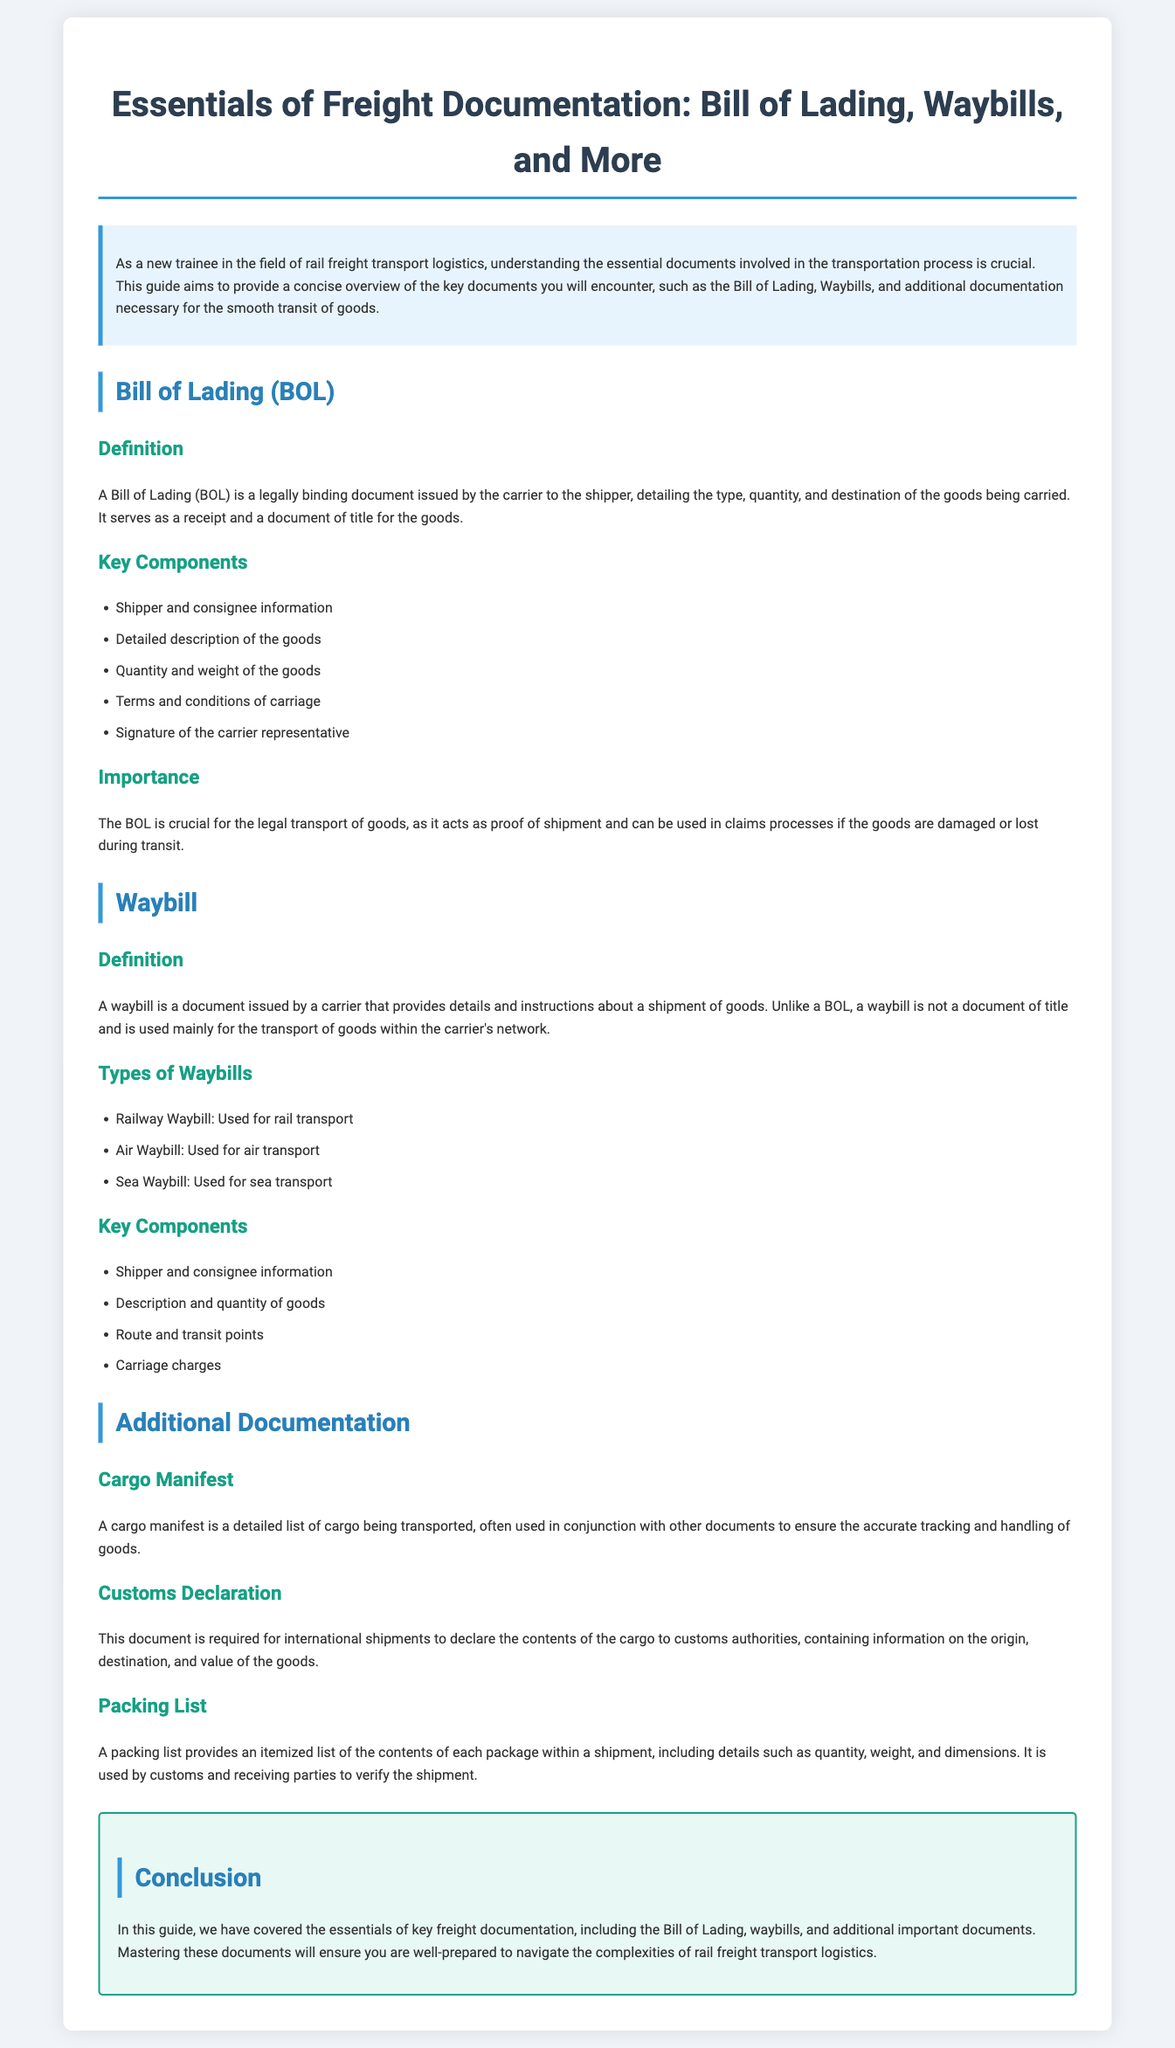What is the main purpose of the Bill of Lading? The main purpose of the Bill of Lading is to document the type, quantity, and destination of the goods being carried, serving as a receipt and a document of title.
Answer: To document the type, quantity, and destination of the goods What are the two main types of freight documents mentioned? The two main types of freight documents mentioned in the guide are the Bill of Lading and Waybills.
Answer: Bill of Lading and Waybills What information is included in a waybill? A waybill includes shipper and consignee information, description and quantity of goods, route, and carriage charges.
Answer: Shipper and consignee information, description and quantity of goods, route, and carriage charges How many key components of a Bill of Lading are listed? The document lists five key components of a Bill of Lading.
Answer: Five What is a Cargo Manifest? A cargo manifest is a detailed list of cargo being transported, often used in conjunction with other documents to ensure the accurate tracking and handling of goods.
Answer: A detailed list of cargo being transported What type of transport uses a Railway Waybill? A Railway Waybill is used for rail transport.
Answer: Rail transport What is the main function of a Customs Declaration? A Customs Declaration declares the contents of cargo to customs authorities for international shipments.
Answer: To declare the contents of cargo to customs authorities What document provides an itemized list of contents in a shipment? A Packing List provides an itemized list of the contents of each package within a shipment.
Answer: Packing List What components are included in the importance of the Bill of Lading? The importance of the Bill of Lading emphasizes its role as proof of shipment and in claims processes if goods are damaged or lost.
Answer: Proof of shipment; claims processes 